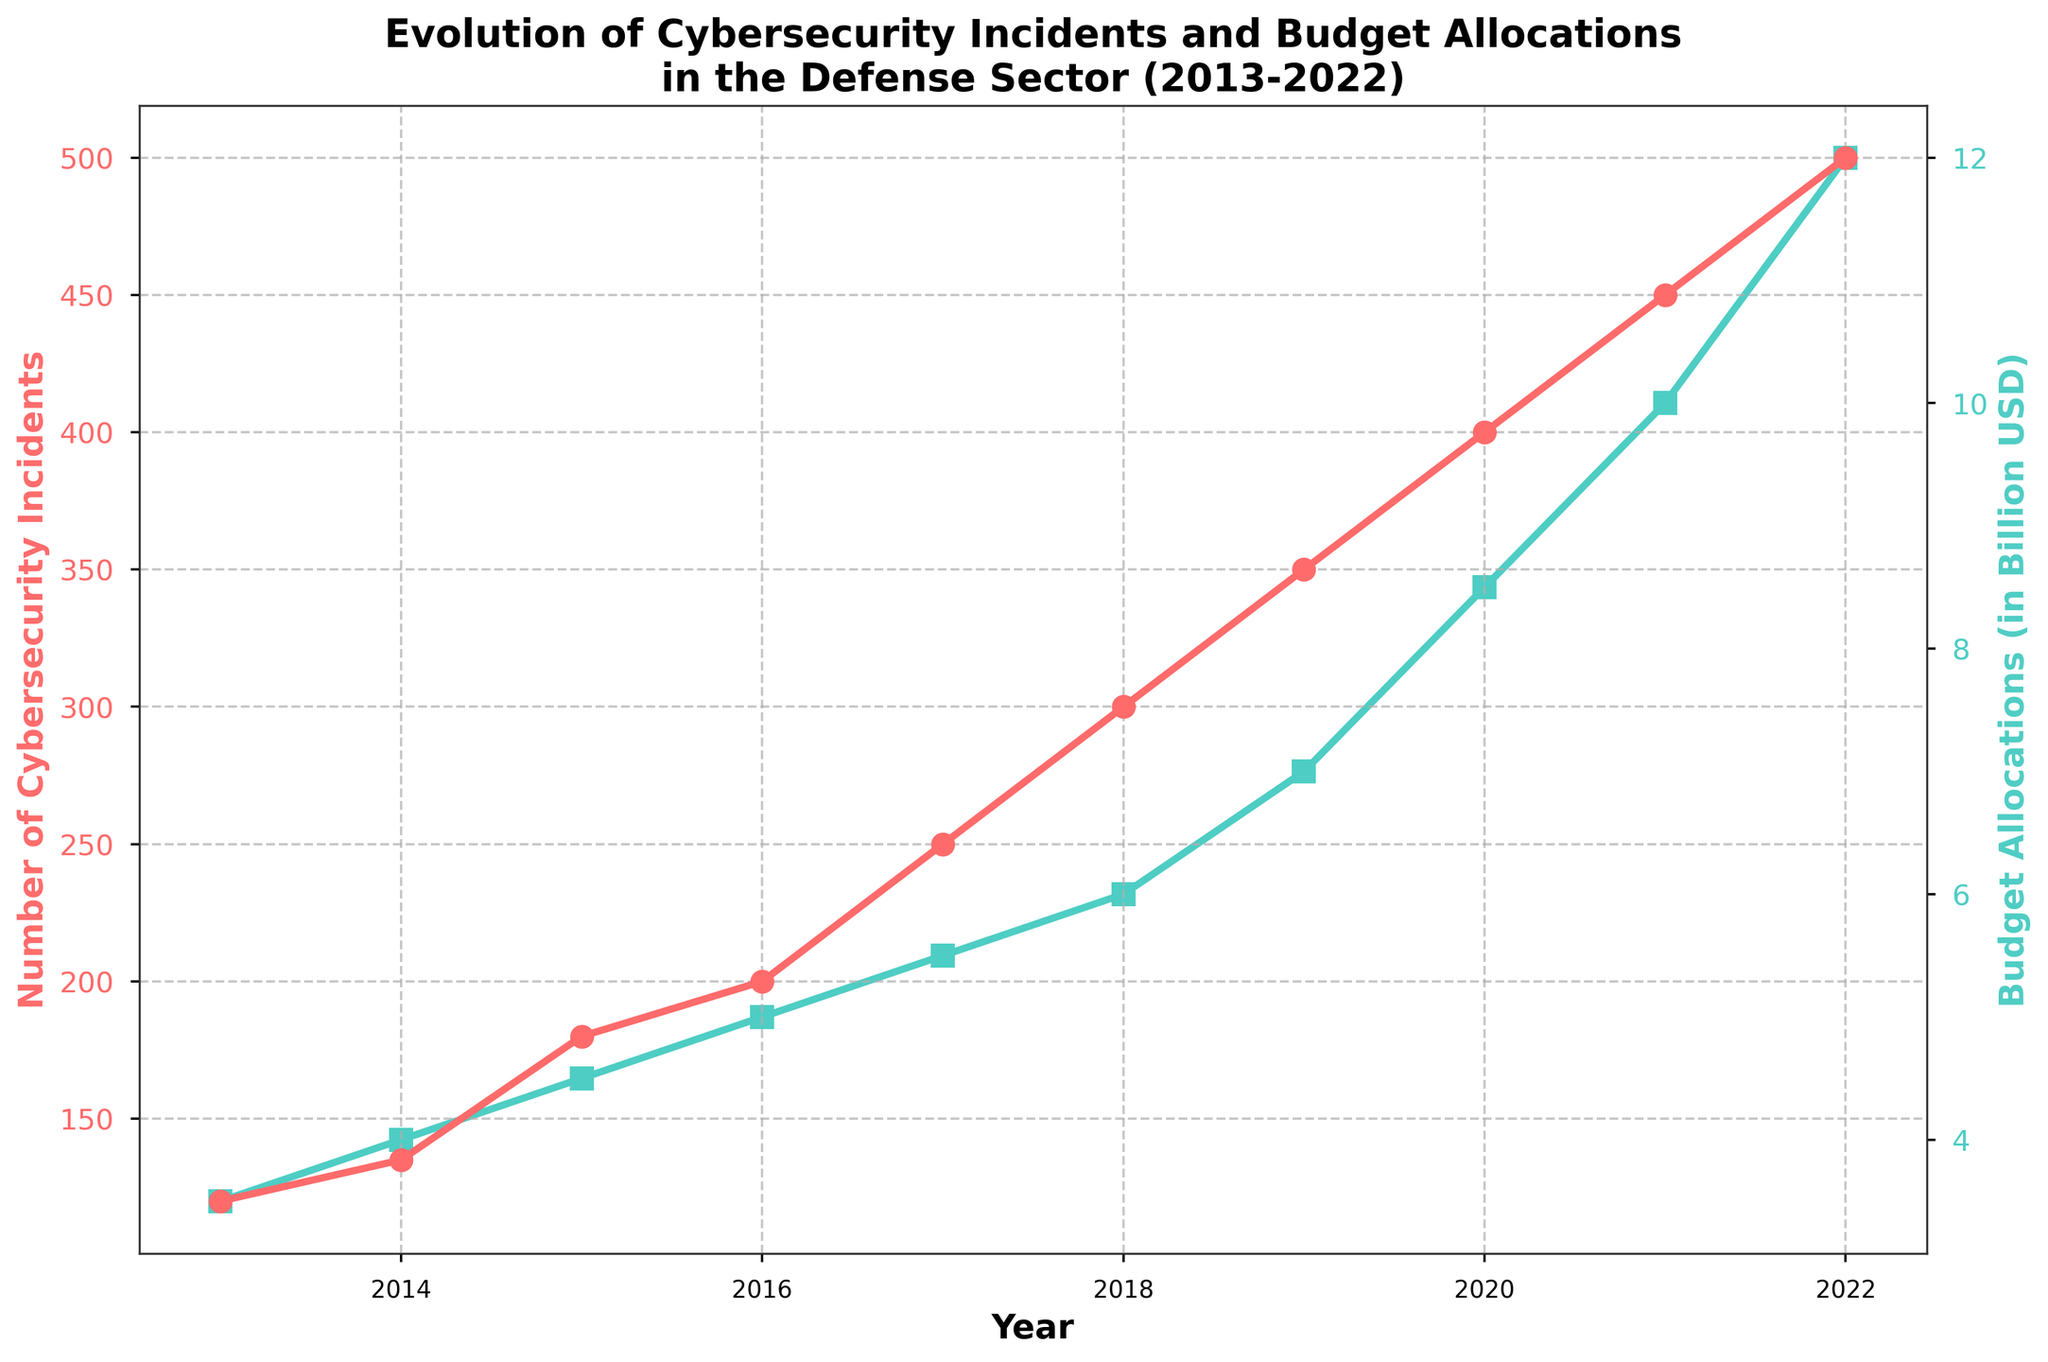What is the title of the figure? The first line of text at the top of a plot usually shows its title. Here, it is written as "Evolution of Cybersecurity Incidents and Budget Allocations\nin the Defense Sector (2013-2022)".
Answer: Evolution of Cybersecurity Incidents and Budget Allocations in the Defense Sector (2013-2022) How many data points are there for both cybersecurity incidents and budget allocations? By counting the number of markers (both circles for incidents and squares for budget allocations) along the x-axis, we see there are 10 points, corresponding to each year from 2013 to 2022.
Answer: 10 Which year experienced the highest number of cybersecurity incidents? By observing the highest point on the red (cybersecurity incidents) line, it corresponds to the year 2022 with the value of 500 incidents.
Answer: 2022 What is the budget allocation in 2020? Locate the data point for the year 2020 on the green (budget allocations) line. The y-axis label indicates it is 8.5 billion USD.
Answer: 8.5 billion USD How does the trend of budget allocations compare to the trend of cybersecurity incidents over the decade? Both the lines show an overall upward trend on the plot, indicating an increase in both cybersecurity incidents and budget allocations over the years, though the scales and rates of increase differ.
Answer: Both are increasing What is the percent increase in the number of cybersecurity incidents from 2013 to 2022? Calculate the growth: ((500 - 120) / 120) * 100%. This results in ((380) / 120) * 100% ≈ 316.67%.
Answer: ~316.67% Between which consecutive years was the largest increase in budget allocation observed? By comparing the vertical distance between consecutive points on the budget allocation line, the largest increase is noticed between 2020 (8.5 billion USD) and 2021 (10.0 billion USD), an increase of 1.5 billion USD.
Answer: 2020 to 2021 What is the average number of cybersecurity incidents per year over the decade? Sum the number of incidents from 2013 to 2022 (120 + 135 + 180 + 200 + 250 + 300 + 350 + 400 + 450 + 500 = 2885), then divide by 10 (2885 / 10 = 288.5).
Answer: 288.5 By how much did the budget allocation increase from 2015 to 2018? Find the difference between the 2018 and 2015 budget values (6.0 billion USD - 4.5 billion USD = 1.5 billion USD).
Answer: 1.5 billion USD Which has a steeper rate of increase: the number of cybersecurity incidents or the budget allocations? Judging by the linear trends, the cybersecurity incidents line increases more sharply compared to the budget allocations over the decade. We can observe the slopes visually.
Answer: Cybersecurity incidents 